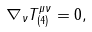Convert formula to latex. <formula><loc_0><loc_0><loc_500><loc_500>\nabla _ { \nu } T ^ { \mu \nu } _ { ( 4 ) } = 0 ,</formula> 